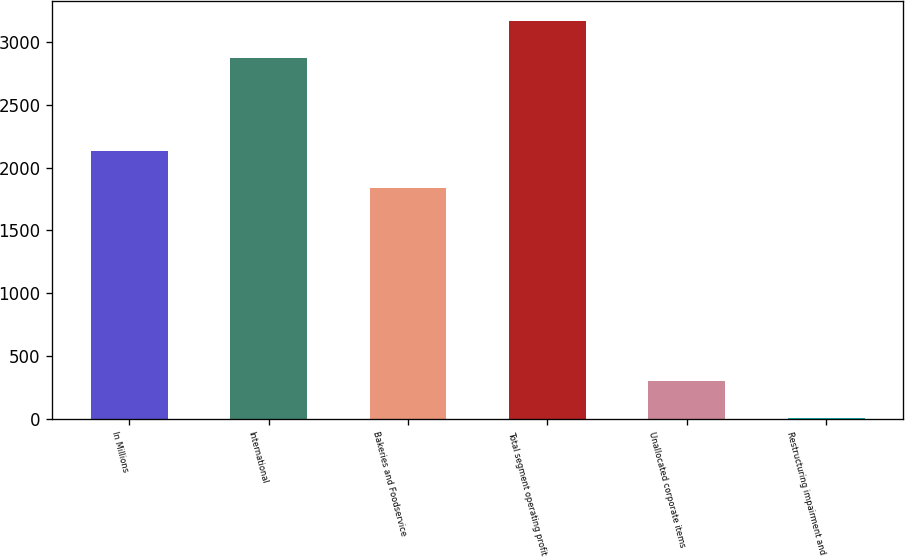Convert chart to OTSL. <chart><loc_0><loc_0><loc_500><loc_500><bar_chart><fcel>In Millions<fcel>International<fcel>Bakeries and Foodservice<fcel>Total segment operating profit<fcel>Unallocated corporate items<fcel>Restructuring impairment and<nl><fcel>2134.92<fcel>2875.5<fcel>1840.8<fcel>3169.62<fcel>298.52<fcel>4.4<nl></chart> 